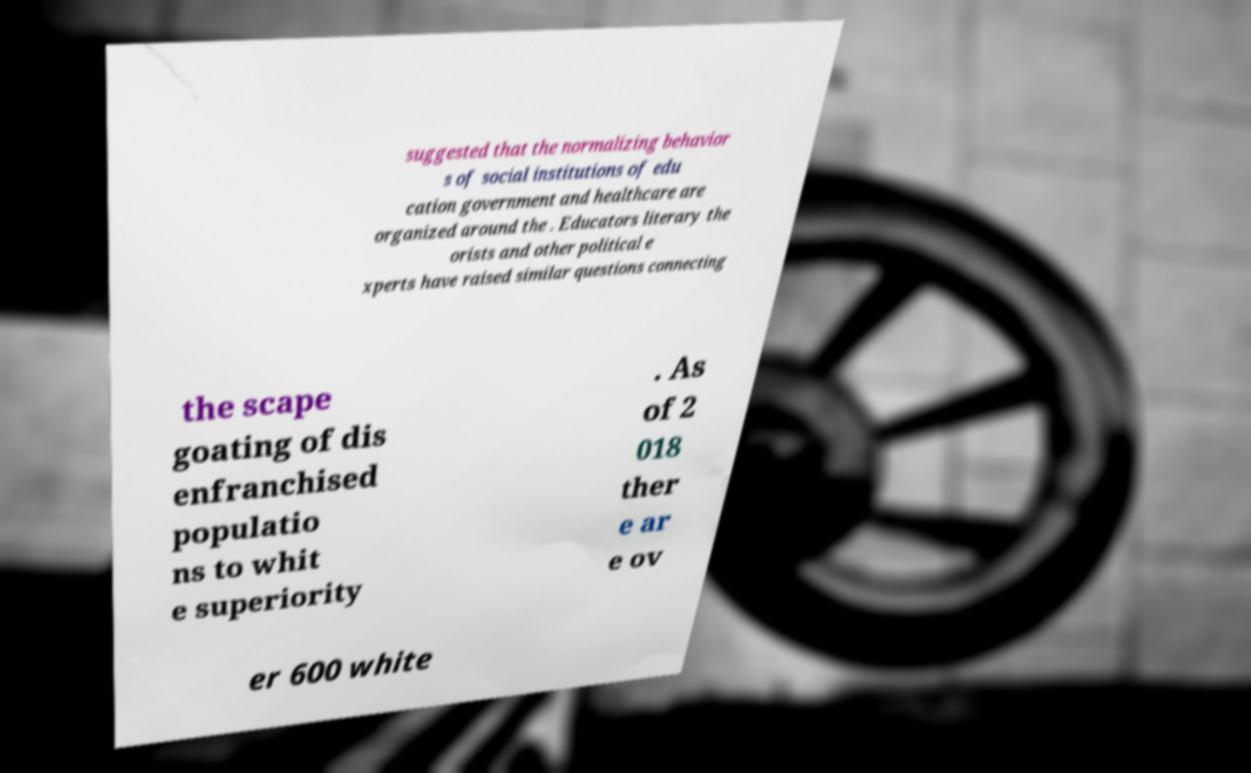What messages or text are displayed in this image? I need them in a readable, typed format. suggested that the normalizing behavior s of social institutions of edu cation government and healthcare are organized around the . Educators literary the orists and other political e xperts have raised similar questions connecting the scape goating of dis enfranchised populatio ns to whit e superiority . As of 2 018 ther e ar e ov er 600 white 